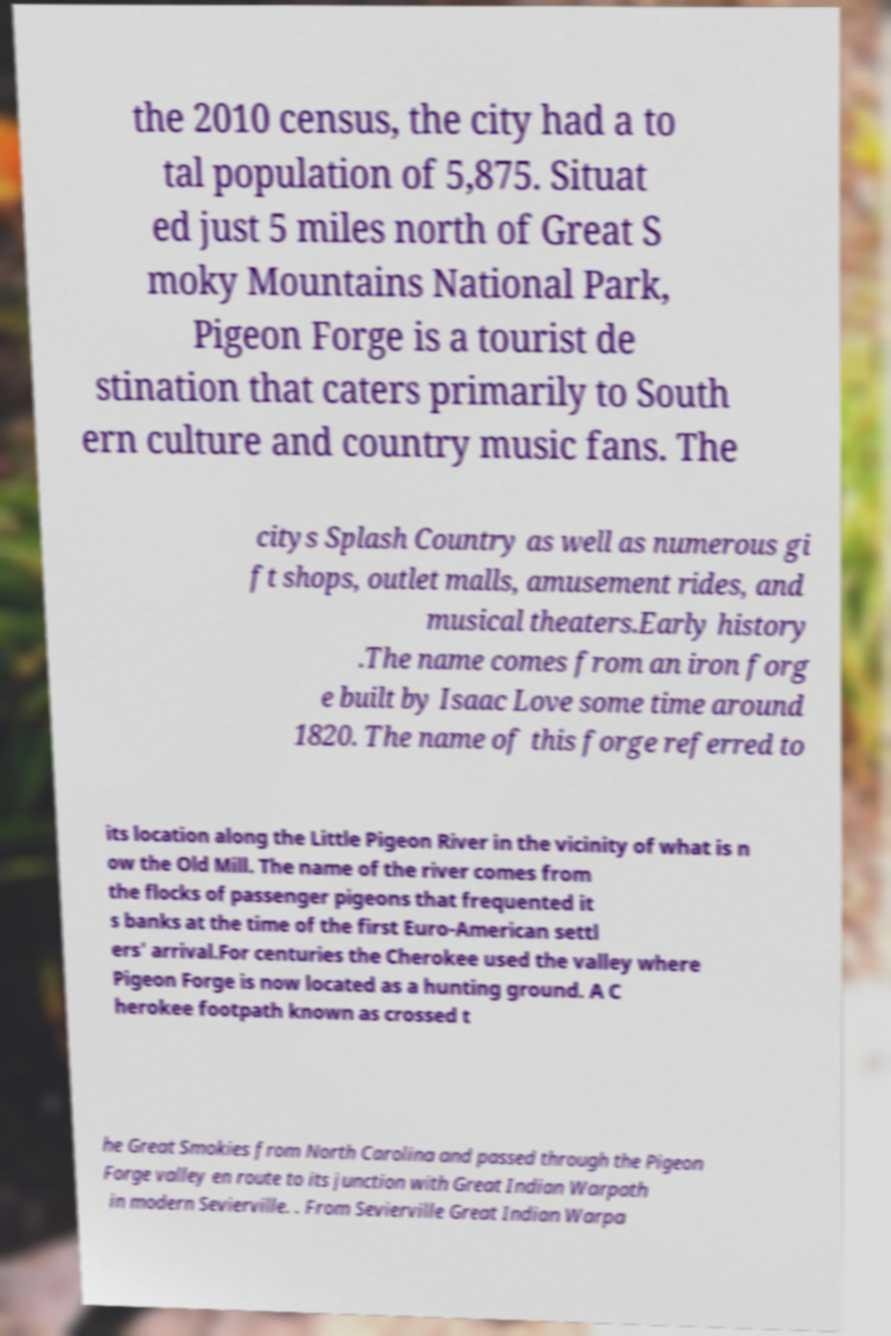There's text embedded in this image that I need extracted. Can you transcribe it verbatim? the 2010 census, the city had a to tal population of 5,875. Situat ed just 5 miles north of Great S moky Mountains National Park, Pigeon Forge is a tourist de stination that caters primarily to South ern culture and country music fans. The citys Splash Country as well as numerous gi ft shops, outlet malls, amusement rides, and musical theaters.Early history .The name comes from an iron forg e built by Isaac Love some time around 1820. The name of this forge referred to its location along the Little Pigeon River in the vicinity of what is n ow the Old Mill. The name of the river comes from the flocks of passenger pigeons that frequented it s banks at the time of the first Euro-American settl ers' arrival.For centuries the Cherokee used the valley where Pigeon Forge is now located as a hunting ground. A C herokee footpath known as crossed t he Great Smokies from North Carolina and passed through the Pigeon Forge valley en route to its junction with Great Indian Warpath in modern Sevierville. . From Sevierville Great Indian Warpa 